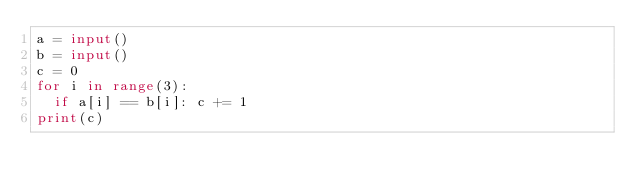Convert code to text. <code><loc_0><loc_0><loc_500><loc_500><_Python_>a = input()
b = input()
c = 0
for i in range(3):
  if a[i] == b[i]: c += 1
print(c)</code> 